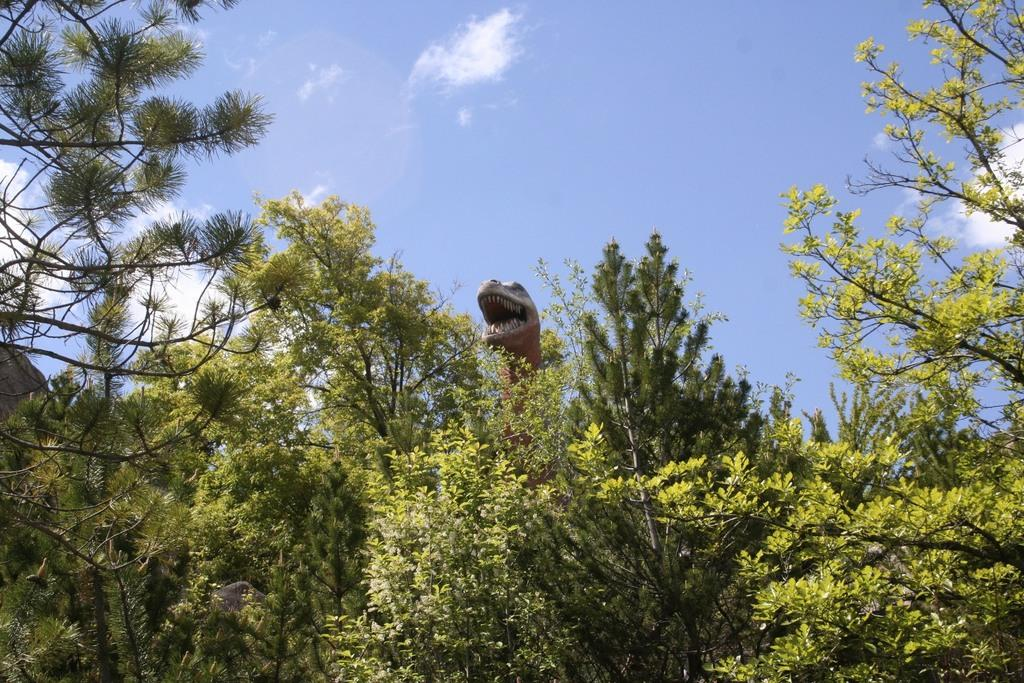What is the main subject in the center of the image? There is a dinosaur in the center of the image. What can be seen in the background of the image? There are many trees in the image. What is the purpose of the jewel in the image? There is no jewel present in the image. 